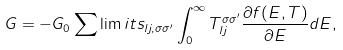Convert formula to latex. <formula><loc_0><loc_0><loc_500><loc_500>G = - G _ { 0 } \sum \lim i t s _ { l j , \sigma \sigma ^ { \prime } } \int _ { 0 } ^ { \infty } T ^ { \sigma \sigma ^ { \prime } } _ { l j } \frac { \partial f ( E , T ) } { \partial E } d E ,</formula> 